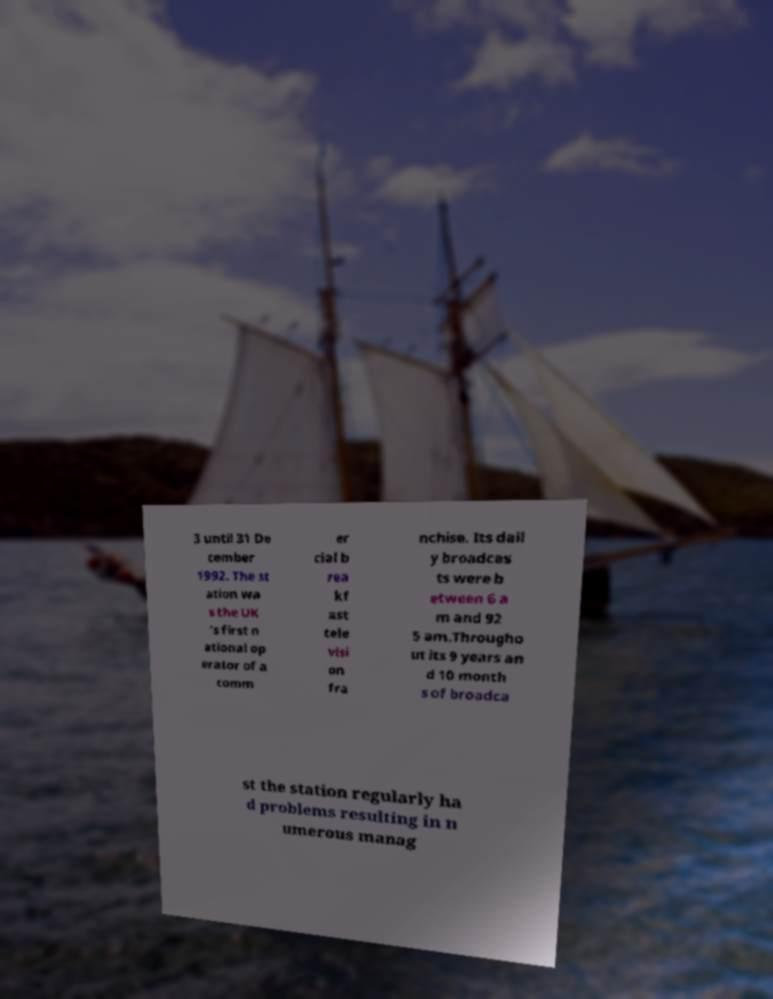Please identify and transcribe the text found in this image. 3 until 31 De cember 1992. The st ation wa s the UK 's first n ational op erator of a comm er cial b rea kf ast tele visi on fra nchise. Its dail y broadcas ts were b etween 6 a m and 92 5 am.Througho ut its 9 years an d 10 month s of broadca st the station regularly ha d problems resulting in n umerous manag 